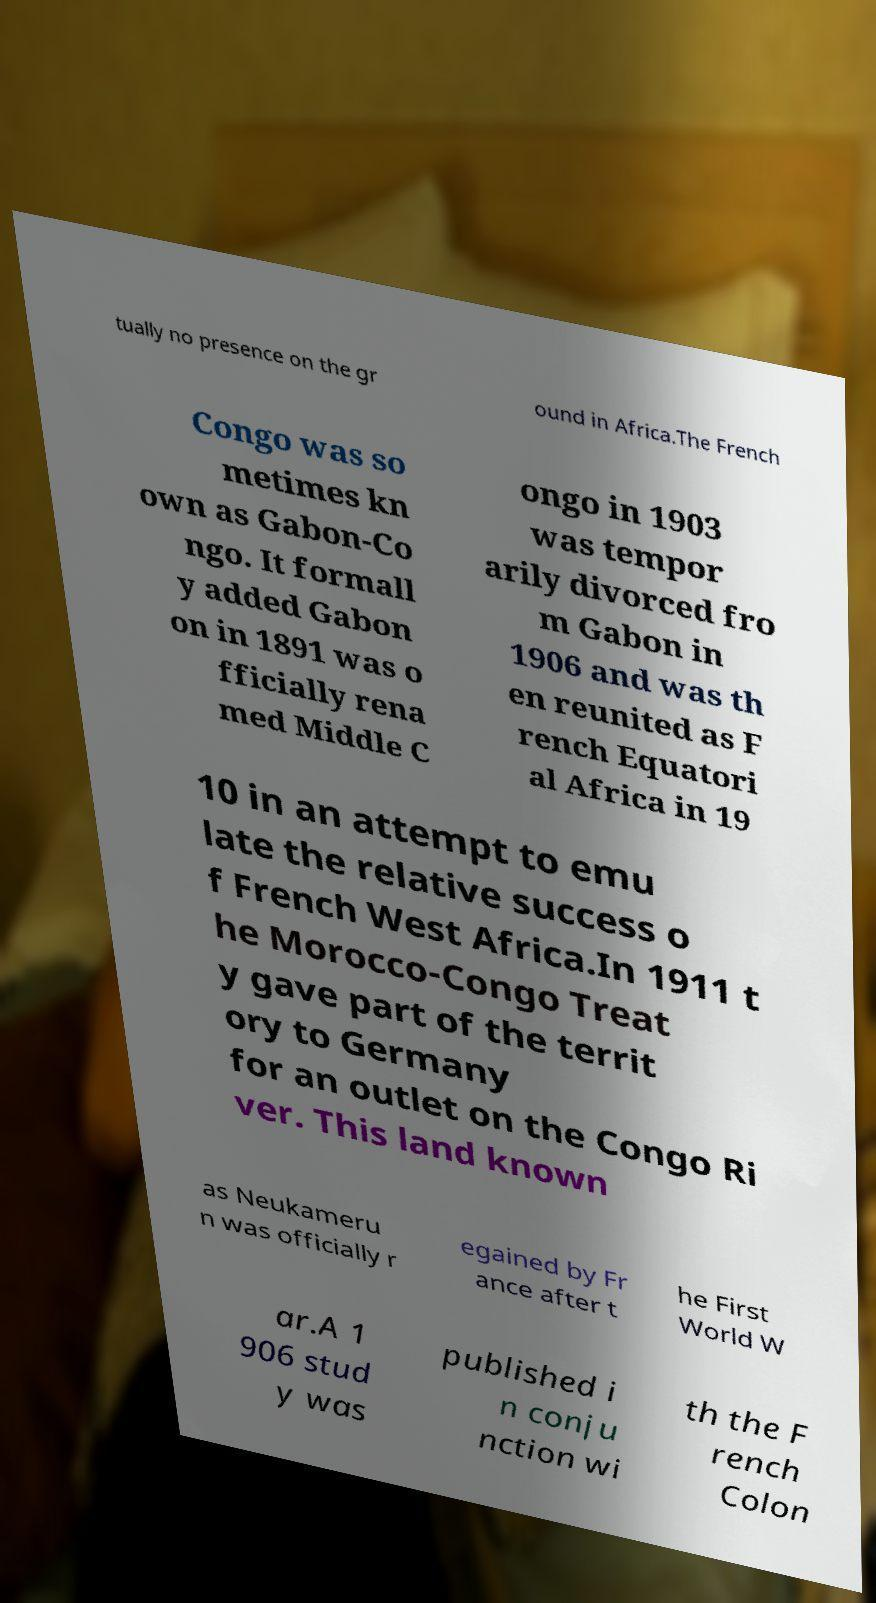Could you assist in decoding the text presented in this image and type it out clearly? tually no presence on the gr ound in Africa.The French Congo was so metimes kn own as Gabon-Co ngo. It formall y added Gabon on in 1891 was o fficially rena med Middle C ongo in 1903 was tempor arily divorced fro m Gabon in 1906 and was th en reunited as F rench Equatori al Africa in 19 10 in an attempt to emu late the relative success o f French West Africa.In 1911 t he Morocco-Congo Treat y gave part of the territ ory to Germany for an outlet on the Congo Ri ver. This land known as Neukameru n was officially r egained by Fr ance after t he First World W ar.A 1 906 stud y was published i n conju nction wi th the F rench Colon 